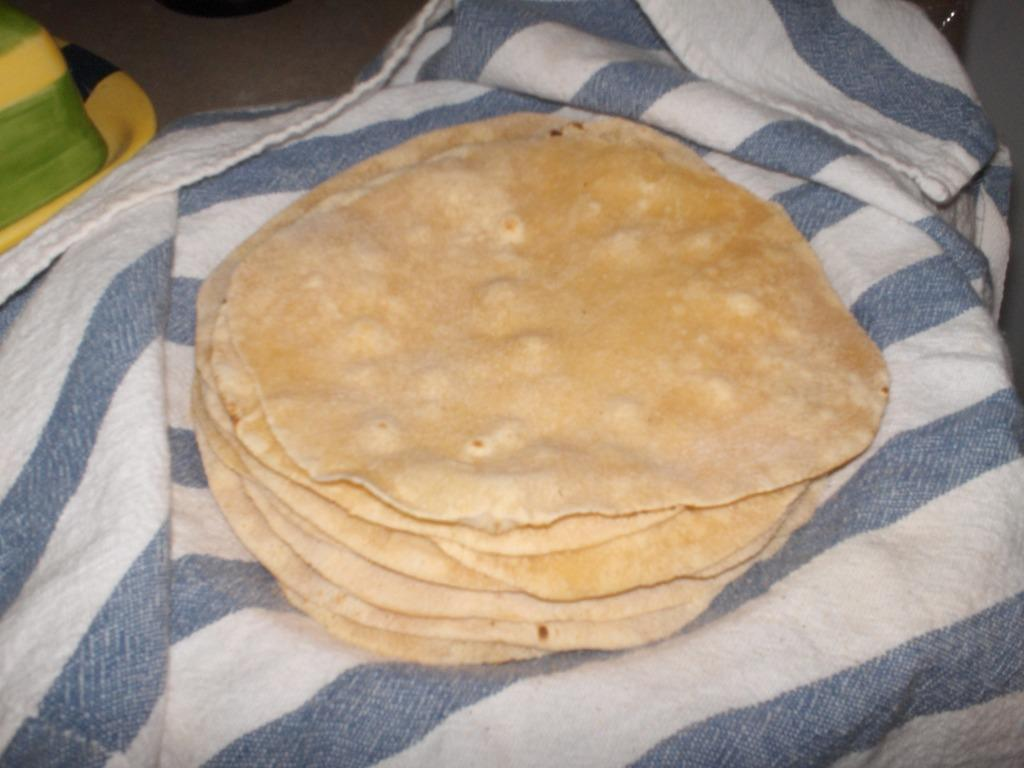What type of bread is present in the image? There are loaves of flat bread in the image. How are the loaves of flat bread arranged or displayed? The loaves of flat bread are on a cloth. Can you describe the object visible at the top left of the image? Unfortunately, the provided facts do not give any information about the object visible at the top left of the image. What type of holiday is being celebrated in the image? There is no indication of a holiday being celebrated in the image. How many horses are visible in the image? There are no horses present in the image. 